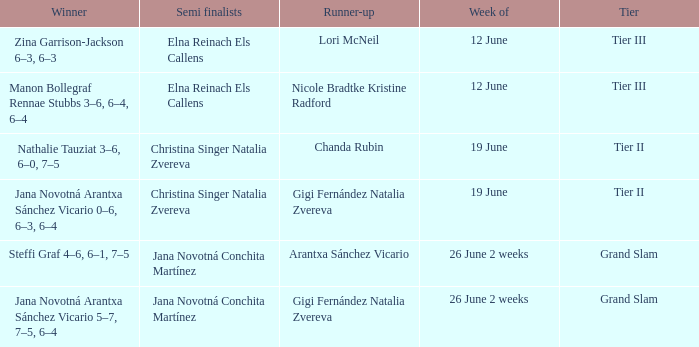Who is the winner in the week listed as 26 June 2 weeks, when the runner-up is Arantxa Sánchez Vicario? Steffi Graf 4–6, 6–1, 7–5. 